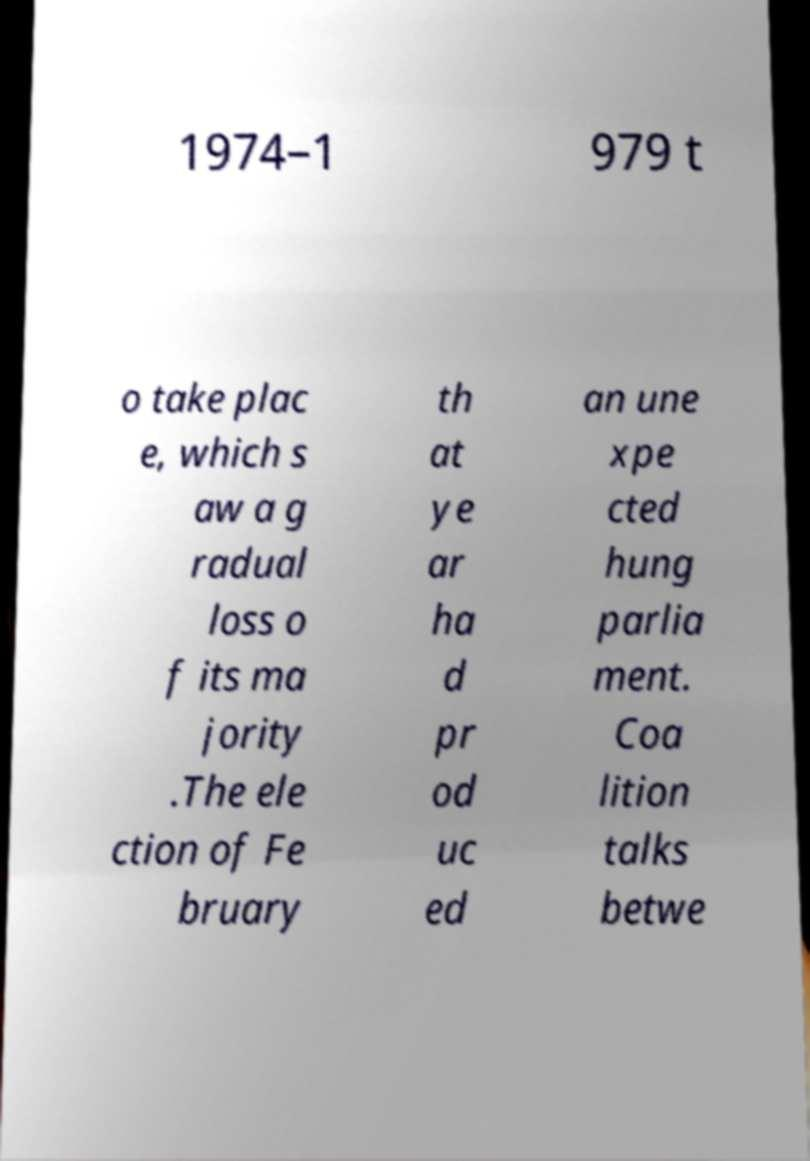What messages or text are displayed in this image? I need them in a readable, typed format. 1974–1 979 t o take plac e, which s aw a g radual loss o f its ma jority .The ele ction of Fe bruary th at ye ar ha d pr od uc ed an une xpe cted hung parlia ment. Coa lition talks betwe 